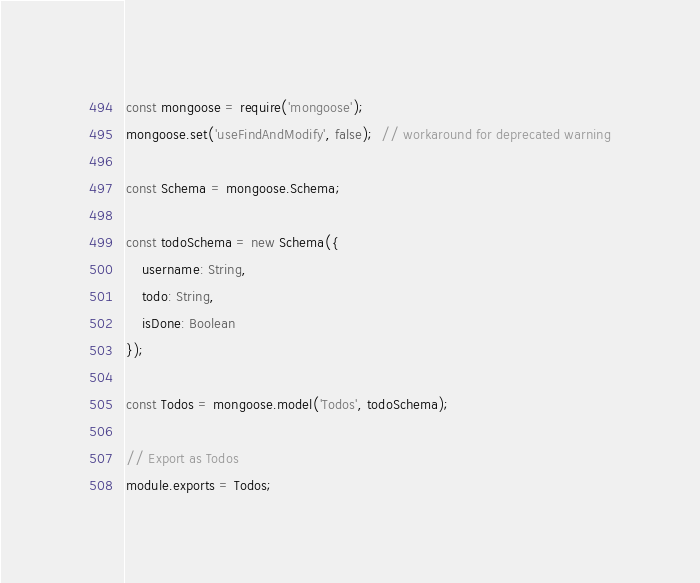<code> <loc_0><loc_0><loc_500><loc_500><_JavaScript_>const mongoose = require('mongoose');
mongoose.set('useFindAndModify', false);  // workaround for deprecated warning

const Schema = mongoose.Schema;

const todoSchema = new Schema({
    username: String,
    todo: String,
    isDone: Boolean
});

const Todos = mongoose.model('Todos', todoSchema);

// Export as Todos
module.exports = Todos;</code> 